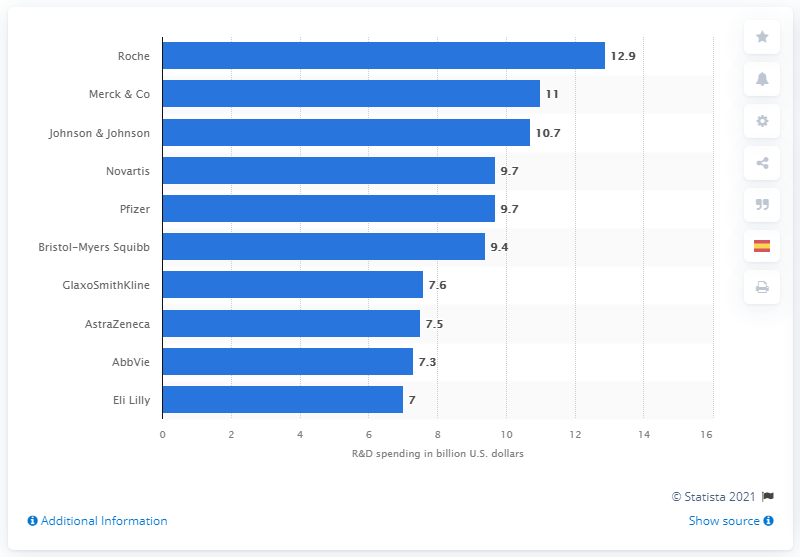Indicate a few pertinent items in this graphic. Roche is projected to spend 12.9 billion US dollars on pharmaceutical research and development in 2026. 